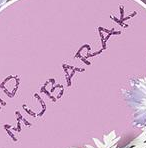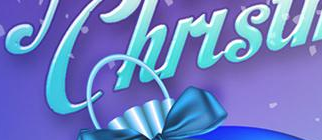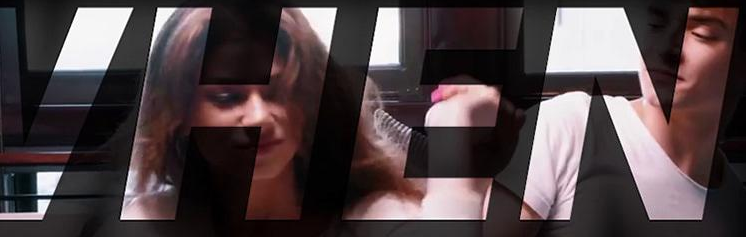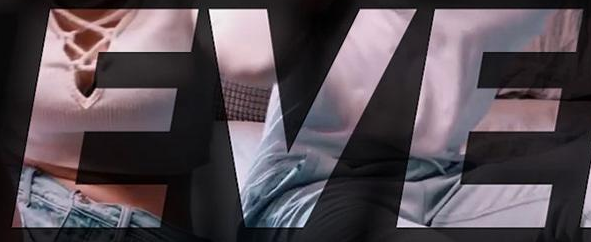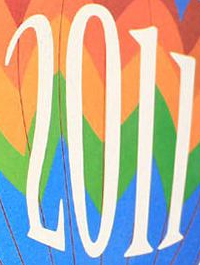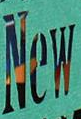What words can you see in these images in sequence, separated by a semicolon? MUBARAK; Chirsu; VHEN; EVE; 2011; New 